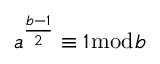Convert formula to latex. <formula><loc_0><loc_0><loc_500><loc_500>a ^ { \frac { b - 1 } { 2 } } \equiv 1 { \bmod { b } }</formula> 